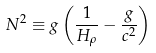<formula> <loc_0><loc_0><loc_500><loc_500>N ^ { 2 } \equiv g \left ( \frac { 1 } { H _ { \rho } } - \frac { g } { c ^ { 2 } } \right )</formula> 